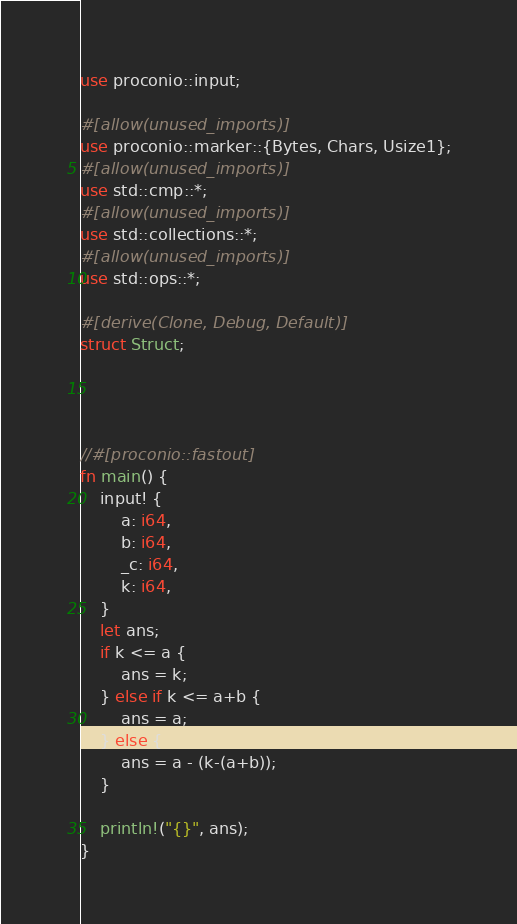<code> <loc_0><loc_0><loc_500><loc_500><_Rust_>use proconio::input;

#[allow(unused_imports)]
use proconio::marker::{Bytes, Chars, Usize1};
#[allow(unused_imports)]
use std::cmp::*;
#[allow(unused_imports)]
use std::collections::*;
#[allow(unused_imports)]
use std::ops::*;

#[derive(Clone, Debug, Default)]
struct Struct;




//#[proconio::fastout]
fn main() {
    input! {
        a: i64,
        b: i64,
        _c: i64,
        k: i64,
    }
    let ans;
    if k <= a {
        ans = k;
    } else if k <= a+b {
        ans = a;
    } else {
        ans = a - (k-(a+b));
    }

    println!("{}", ans);
}

</code> 